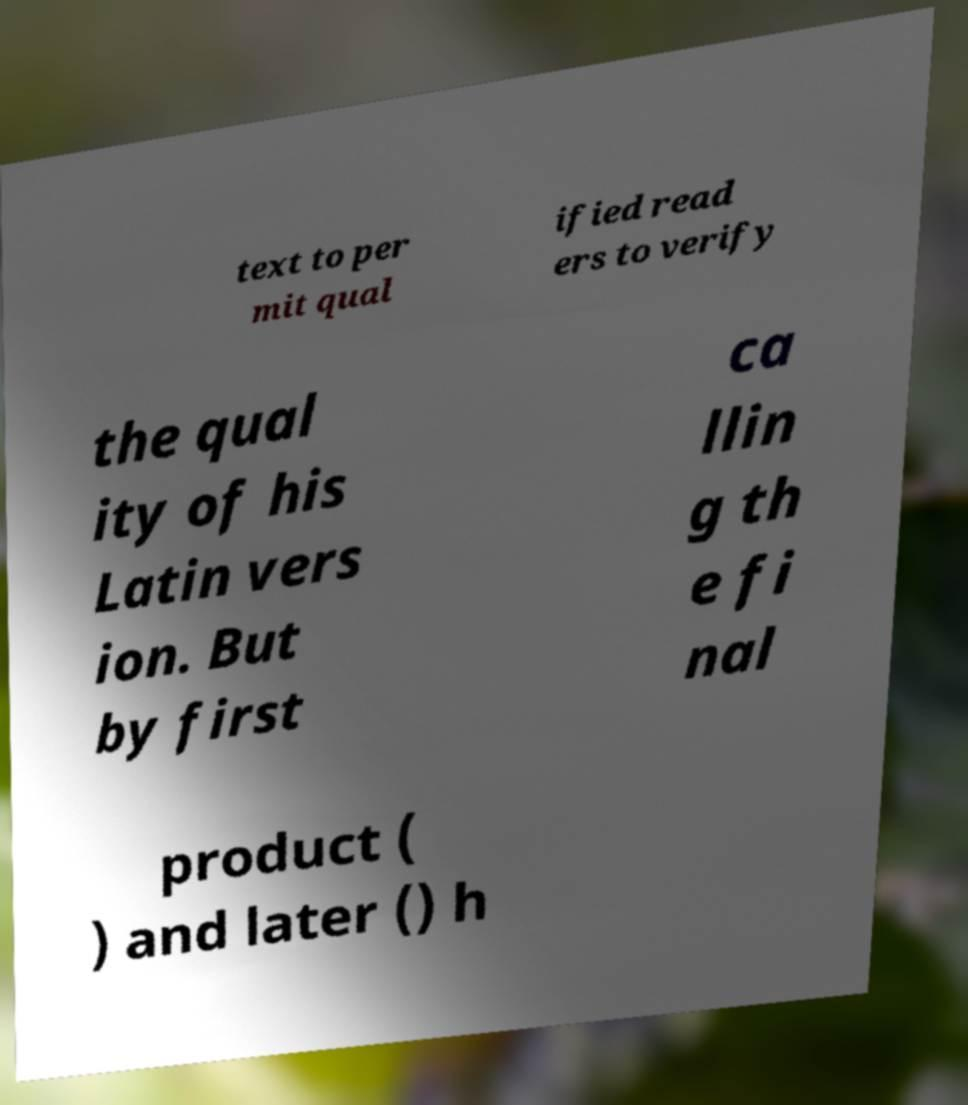There's text embedded in this image that I need extracted. Can you transcribe it verbatim? text to per mit qual ified read ers to verify the qual ity of his Latin vers ion. But by first ca llin g th e fi nal product ( ) and later () h 